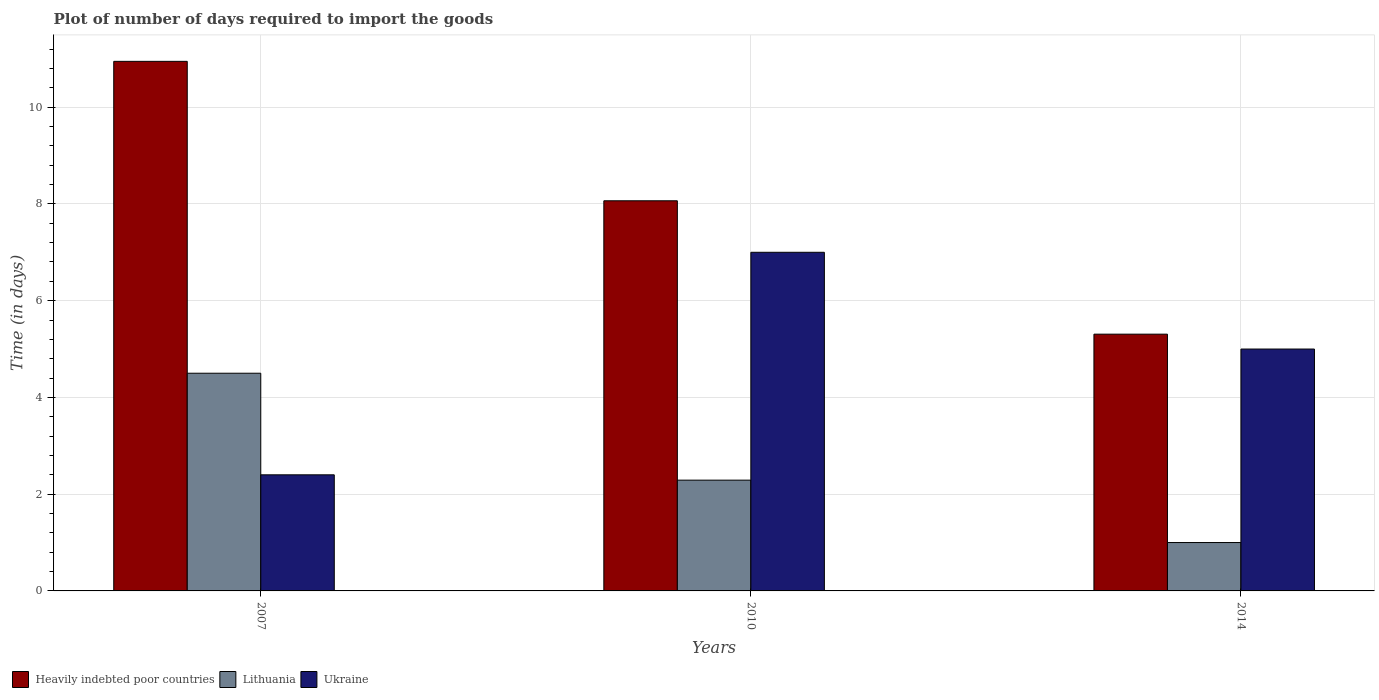How many different coloured bars are there?
Offer a terse response. 3. Are the number of bars on each tick of the X-axis equal?
Give a very brief answer. Yes. How many bars are there on the 2nd tick from the left?
Make the answer very short. 3. How many bars are there on the 3rd tick from the right?
Your answer should be very brief. 3. In how many cases, is the number of bars for a given year not equal to the number of legend labels?
Provide a short and direct response. 0. What is the time required to import goods in Lithuania in 2010?
Your response must be concise. 2.29. Across all years, what is the maximum time required to import goods in Heavily indebted poor countries?
Your answer should be very brief. 10.95. What is the total time required to import goods in Lithuania in the graph?
Provide a short and direct response. 7.79. What is the difference between the time required to import goods in Ukraine in 2007 and the time required to import goods in Heavily indebted poor countries in 2014?
Keep it short and to the point. -2.91. What is the average time required to import goods in Lithuania per year?
Your response must be concise. 2.6. In how many years, is the time required to import goods in Heavily indebted poor countries greater than 10 days?
Keep it short and to the point. 1. What is the ratio of the time required to import goods in Lithuania in 2007 to that in 2014?
Your response must be concise. 4.5. Is the difference between the time required to import goods in Lithuania in 2007 and 2014 greater than the difference between the time required to import goods in Ukraine in 2007 and 2014?
Your answer should be compact. Yes. What is the difference between the highest and the second highest time required to import goods in Ukraine?
Your response must be concise. 2. What is the difference between the highest and the lowest time required to import goods in Heavily indebted poor countries?
Offer a terse response. 5.64. In how many years, is the time required to import goods in Heavily indebted poor countries greater than the average time required to import goods in Heavily indebted poor countries taken over all years?
Keep it short and to the point. 1. What does the 3rd bar from the left in 2014 represents?
Offer a very short reply. Ukraine. What does the 1st bar from the right in 2007 represents?
Give a very brief answer. Ukraine. Is it the case that in every year, the sum of the time required to import goods in Lithuania and time required to import goods in Heavily indebted poor countries is greater than the time required to import goods in Ukraine?
Your answer should be compact. Yes. Are all the bars in the graph horizontal?
Your response must be concise. No. Does the graph contain grids?
Provide a succinct answer. Yes. How many legend labels are there?
Your answer should be very brief. 3. What is the title of the graph?
Keep it short and to the point. Plot of number of days required to import the goods. What is the label or title of the Y-axis?
Make the answer very short. Time (in days). What is the Time (in days) in Heavily indebted poor countries in 2007?
Provide a succinct answer. 10.95. What is the Time (in days) of Lithuania in 2007?
Ensure brevity in your answer.  4.5. What is the Time (in days) of Heavily indebted poor countries in 2010?
Make the answer very short. 8.06. What is the Time (in days) in Lithuania in 2010?
Give a very brief answer. 2.29. What is the Time (in days) of Heavily indebted poor countries in 2014?
Provide a succinct answer. 5.31. Across all years, what is the maximum Time (in days) in Heavily indebted poor countries?
Make the answer very short. 10.95. Across all years, what is the maximum Time (in days) in Lithuania?
Your answer should be very brief. 4.5. Across all years, what is the maximum Time (in days) in Ukraine?
Make the answer very short. 7. Across all years, what is the minimum Time (in days) in Heavily indebted poor countries?
Give a very brief answer. 5.31. Across all years, what is the minimum Time (in days) of Lithuania?
Your answer should be very brief. 1. What is the total Time (in days) of Heavily indebted poor countries in the graph?
Offer a terse response. 24.32. What is the total Time (in days) of Lithuania in the graph?
Ensure brevity in your answer.  7.79. What is the total Time (in days) in Ukraine in the graph?
Make the answer very short. 14.4. What is the difference between the Time (in days) in Heavily indebted poor countries in 2007 and that in 2010?
Offer a terse response. 2.88. What is the difference between the Time (in days) of Lithuania in 2007 and that in 2010?
Keep it short and to the point. 2.21. What is the difference between the Time (in days) in Heavily indebted poor countries in 2007 and that in 2014?
Offer a terse response. 5.64. What is the difference between the Time (in days) of Ukraine in 2007 and that in 2014?
Ensure brevity in your answer.  -2.6. What is the difference between the Time (in days) in Heavily indebted poor countries in 2010 and that in 2014?
Offer a terse response. 2.76. What is the difference between the Time (in days) of Lithuania in 2010 and that in 2014?
Provide a short and direct response. 1.29. What is the difference between the Time (in days) in Ukraine in 2010 and that in 2014?
Make the answer very short. 2. What is the difference between the Time (in days) of Heavily indebted poor countries in 2007 and the Time (in days) of Lithuania in 2010?
Give a very brief answer. 8.66. What is the difference between the Time (in days) of Heavily indebted poor countries in 2007 and the Time (in days) of Ukraine in 2010?
Your answer should be very brief. 3.95. What is the difference between the Time (in days) of Heavily indebted poor countries in 2007 and the Time (in days) of Lithuania in 2014?
Your response must be concise. 9.95. What is the difference between the Time (in days) of Heavily indebted poor countries in 2007 and the Time (in days) of Ukraine in 2014?
Make the answer very short. 5.95. What is the difference between the Time (in days) in Heavily indebted poor countries in 2010 and the Time (in days) in Lithuania in 2014?
Give a very brief answer. 7.06. What is the difference between the Time (in days) of Heavily indebted poor countries in 2010 and the Time (in days) of Ukraine in 2014?
Give a very brief answer. 3.06. What is the difference between the Time (in days) in Lithuania in 2010 and the Time (in days) in Ukraine in 2014?
Make the answer very short. -2.71. What is the average Time (in days) of Heavily indebted poor countries per year?
Offer a terse response. 8.11. What is the average Time (in days) of Lithuania per year?
Your answer should be very brief. 2.6. What is the average Time (in days) of Ukraine per year?
Make the answer very short. 4.8. In the year 2007, what is the difference between the Time (in days) of Heavily indebted poor countries and Time (in days) of Lithuania?
Keep it short and to the point. 6.45. In the year 2007, what is the difference between the Time (in days) in Heavily indebted poor countries and Time (in days) in Ukraine?
Give a very brief answer. 8.55. In the year 2010, what is the difference between the Time (in days) in Heavily indebted poor countries and Time (in days) in Lithuania?
Provide a succinct answer. 5.77. In the year 2010, what is the difference between the Time (in days) in Heavily indebted poor countries and Time (in days) in Ukraine?
Make the answer very short. 1.06. In the year 2010, what is the difference between the Time (in days) in Lithuania and Time (in days) in Ukraine?
Offer a terse response. -4.71. In the year 2014, what is the difference between the Time (in days) of Heavily indebted poor countries and Time (in days) of Lithuania?
Your answer should be very brief. 4.31. In the year 2014, what is the difference between the Time (in days) in Heavily indebted poor countries and Time (in days) in Ukraine?
Make the answer very short. 0.31. What is the ratio of the Time (in days) of Heavily indebted poor countries in 2007 to that in 2010?
Make the answer very short. 1.36. What is the ratio of the Time (in days) in Lithuania in 2007 to that in 2010?
Provide a short and direct response. 1.97. What is the ratio of the Time (in days) of Ukraine in 2007 to that in 2010?
Offer a very short reply. 0.34. What is the ratio of the Time (in days) of Heavily indebted poor countries in 2007 to that in 2014?
Offer a terse response. 2.06. What is the ratio of the Time (in days) of Lithuania in 2007 to that in 2014?
Your response must be concise. 4.5. What is the ratio of the Time (in days) in Ukraine in 2007 to that in 2014?
Provide a succinct answer. 0.48. What is the ratio of the Time (in days) of Heavily indebted poor countries in 2010 to that in 2014?
Your answer should be compact. 1.52. What is the ratio of the Time (in days) in Lithuania in 2010 to that in 2014?
Provide a short and direct response. 2.29. What is the ratio of the Time (in days) in Ukraine in 2010 to that in 2014?
Your answer should be compact. 1.4. What is the difference between the highest and the second highest Time (in days) in Heavily indebted poor countries?
Provide a short and direct response. 2.88. What is the difference between the highest and the second highest Time (in days) of Lithuania?
Your response must be concise. 2.21. What is the difference between the highest and the lowest Time (in days) in Heavily indebted poor countries?
Offer a very short reply. 5.64. 